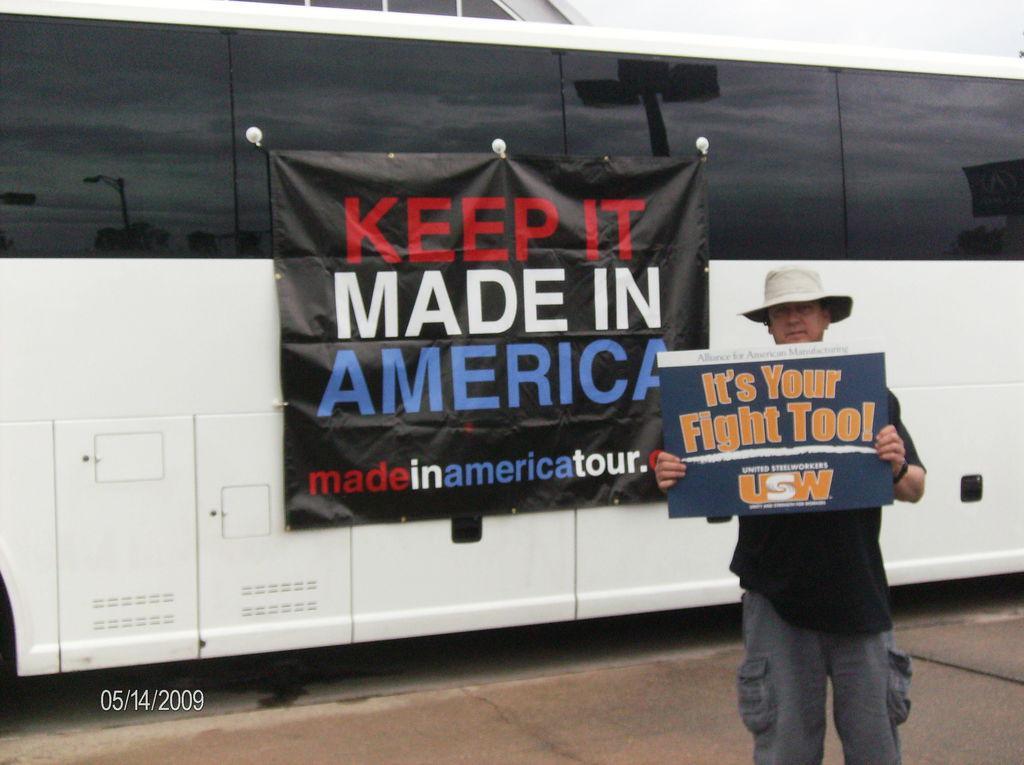How would you summarize this image in a sentence or two? In this image we can see a man standing on the floor and holding an advertisement in his hands. In the background there is a motor vehicle to which an advertisement is hanged. 